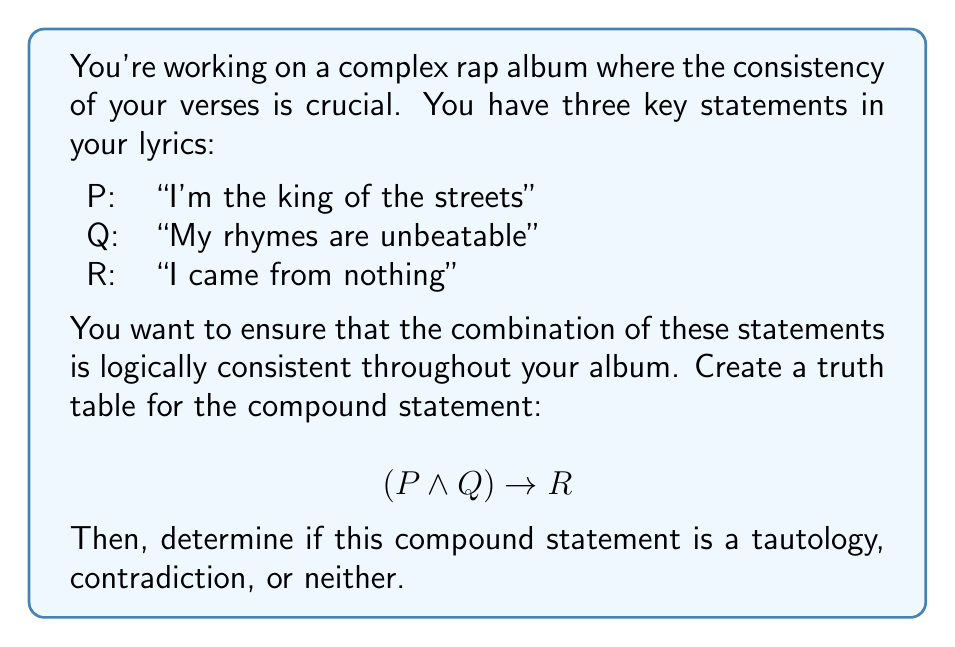Solve this math problem. Let's approach this step-by-step:

1) First, we need to create a truth table for the compound statement $(P \wedge Q) \rightarrow R$. A truth table will have $2^3 = 8$ rows, as we have three variables.

2) Let's construct the truth table:

   | P | Q | R | P ∧ Q | (P ∧ Q) → R |
   |---|---|---|-------|-------------|
   | T | T | T |   T   |      T      |
   | T | T | F |   T   |      F      |
   | T | F | T |   F   |      T      |
   | T | F | F |   F   |      T      |
   | F | T | T |   F   |      T      |
   | F | T | F |   F   |      T      |
   | F | F | T |   F   |      T      |
   | F | F | F |   F   |      T      |

3) To fill in the "P ∧ Q" column, we use the truth table for AND (∧):
   - T ∧ T = T
   - T ∧ F = F
   - F ∧ T = F
   - F ∧ F = F

4) For the last column "(P ∧ Q) → R", we use the truth table for implication (→):
   - T → T = T
   - T → F = F
   - F → T = T
   - F → F = T

5) Now, let's analyze the result:
   - The compound statement is true in all cases except one (when P and Q are true, but R is false).
   - This means it's not a tautology (true in all cases) or a contradiction (false in all cases).

6) In the context of your rap lyrics, this means:
   - Your verses are logically consistent in most cases.
   - The only inconsistency occurs when you claim to be "the king of the streets" AND your "rhymes are unbeatable", but you didn't "come from nothing".
Answer: The compound statement $(P \wedge Q) \rightarrow R$ is neither a tautology nor a contradiction. It's a contingency, meaning its truth value depends on the truth values of its component statements. 